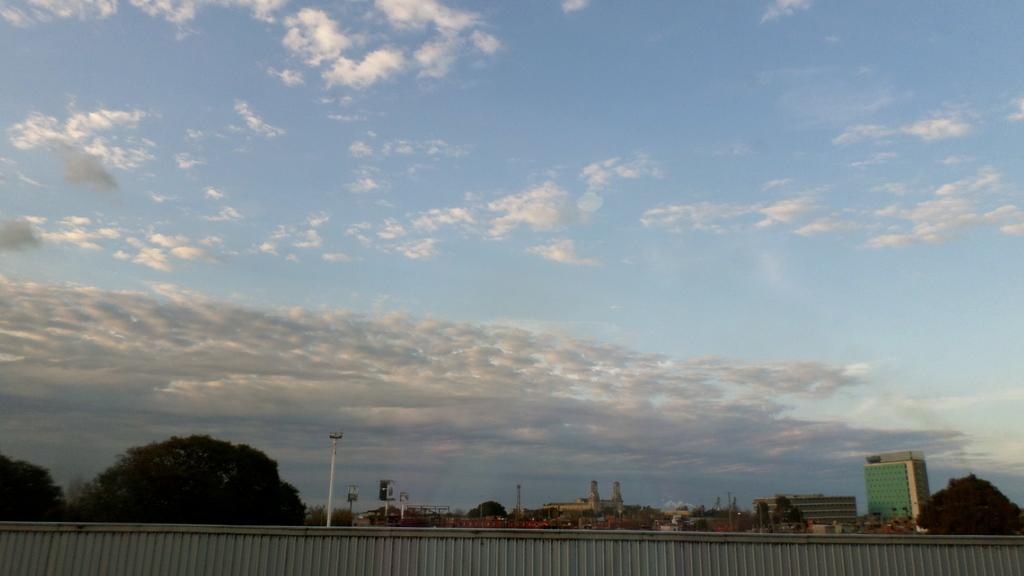Please provide a concise description of this image. We can see wall. In the background we can see buildings,poles,hoardings,trees and sky is cloudy. 